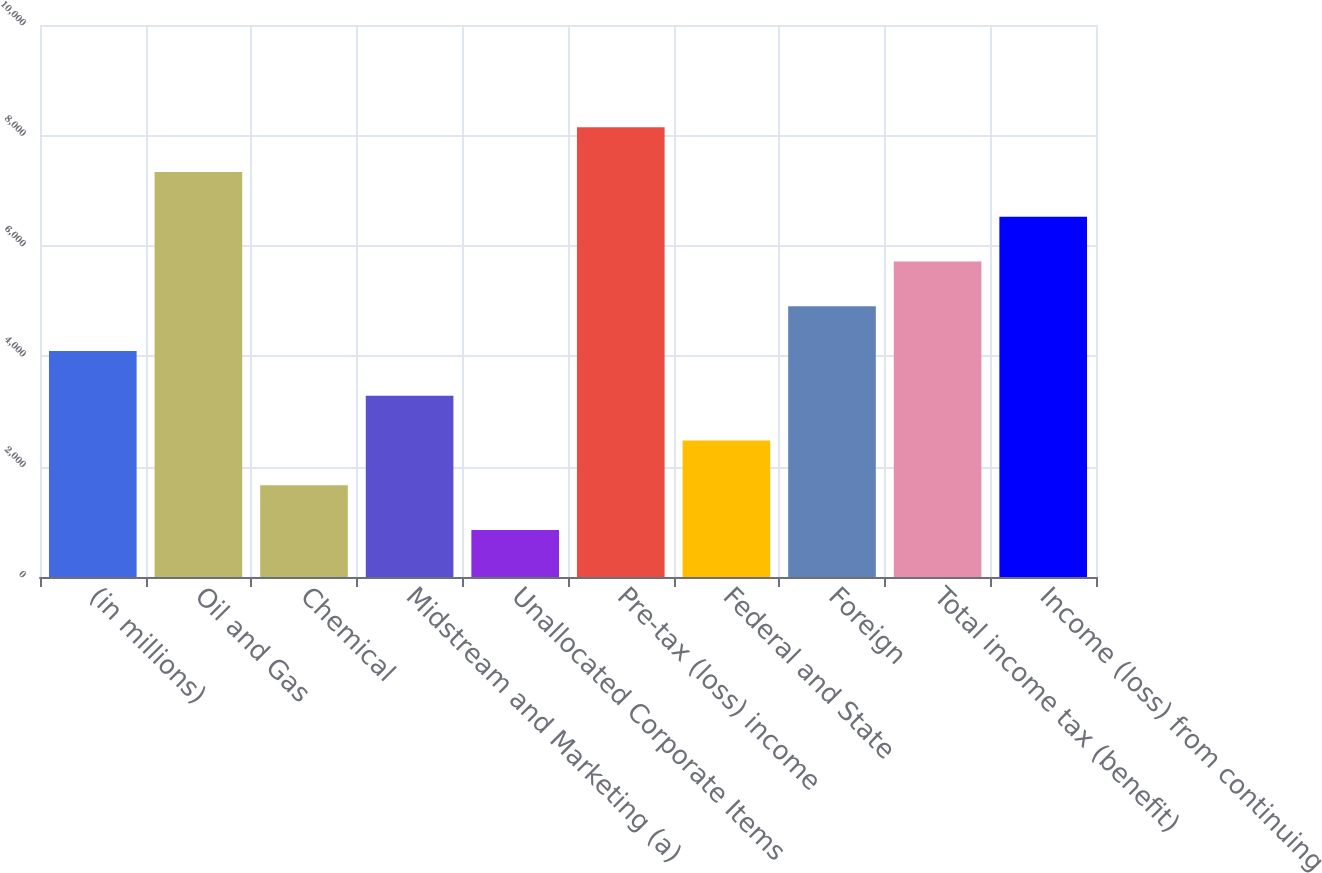Convert chart. <chart><loc_0><loc_0><loc_500><loc_500><bar_chart><fcel>(in millions)<fcel>Oil and Gas<fcel>Chemical<fcel>Midstream and Marketing (a)<fcel>Unallocated Corporate Items<fcel>Pre-tax (loss) income<fcel>Federal and State<fcel>Foreign<fcel>Total income tax (benefit)<fcel>Income (loss) from continuing<nl><fcel>4093<fcel>7335.4<fcel>1661.2<fcel>3282.4<fcel>850.6<fcel>8146<fcel>2471.8<fcel>4903.6<fcel>5714.2<fcel>6524.8<nl></chart> 